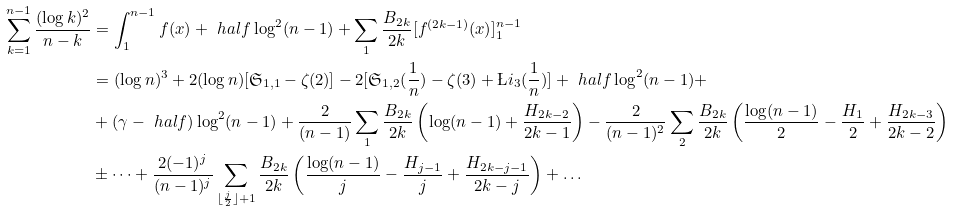Convert formula to latex. <formula><loc_0><loc_0><loc_500><loc_500>\sum _ { k = 1 } ^ { n - 1 } \frac { ( \log k ) ^ { 2 } } { n - k } & = \int _ { 1 } ^ { n - 1 } f ( x ) + \ h a l f \log ^ { 2 } ( n - 1 ) + \sum _ { 1 } \frac { B _ { 2 k } } { 2 k } [ f ^ { ( 2 k - 1 ) } ( x ) ] ^ { n - 1 } _ { 1 } \\ & = ( \log n ) ^ { 3 } + 2 ( \log n ) [ \mathfrak { S } _ { 1 , 1 } - \zeta ( 2 ) ] - 2 [ \mathfrak { S } _ { 1 , 2 } ( \frac { 1 } { n } ) - \zeta ( 3 ) + \L i _ { 3 } ( \frac { 1 } { n } ) ] + \ h a l f \log ^ { 2 } ( n - 1 ) + \\ & + ( \gamma - \ h a l f ) \log ^ { 2 } ( n - 1 ) + \frac { 2 } { ( n - 1 ) } \sum _ { 1 } \frac { B _ { 2 k } } { 2 k } \left ( \log ( n - 1 ) + \frac { H _ { 2 k - 2 } } { 2 k - 1 } \right ) - \frac { 2 } { ( n - 1 ) ^ { 2 } } \sum _ { 2 } \frac { B _ { 2 k } } { 2 k } \left ( \frac { \log ( n - 1 ) } { 2 } - \frac { H _ { 1 } } { 2 } + \frac { H _ { 2 k - 3 } } { 2 k - 2 } \right ) \\ & \pm \dots + \frac { 2 ( - 1 ) ^ { j } } { ( n - 1 ) ^ { j } } \sum _ { \lfloor \frac { j } { 2 } \rfloor + 1 } \frac { B _ { 2 k } } { 2 k } \left ( \frac { \log ( n - 1 ) } { j } - \frac { H _ { j - 1 } } { j } + \frac { H _ { 2 k - j - 1 } } { 2 k - j } \right ) + \dots</formula> 